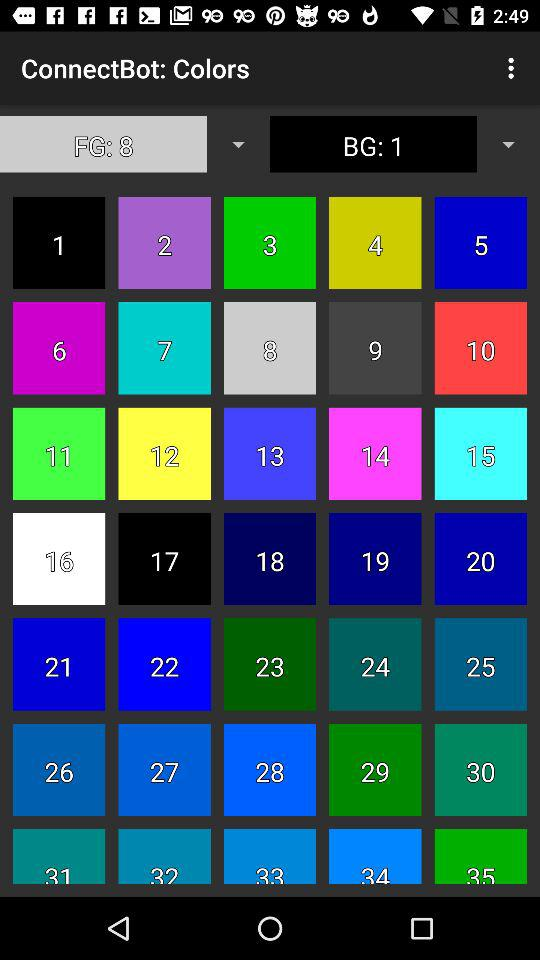How many total colours are visible? The total visible colours are 35. 